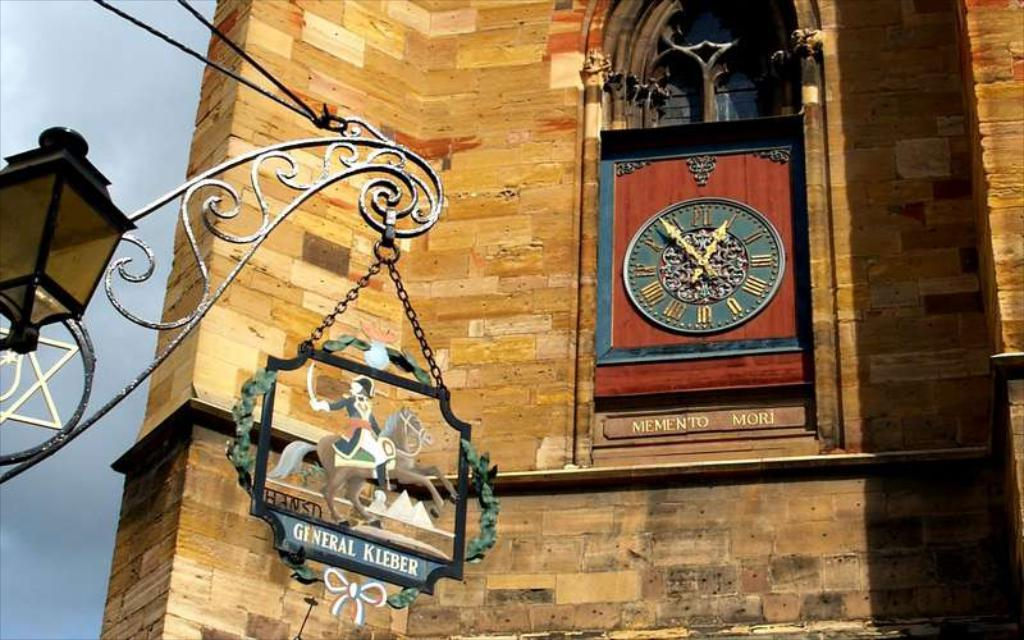Provide a one-sentence caption for the provided image. A fancy clock on a building reading General Kleber. 